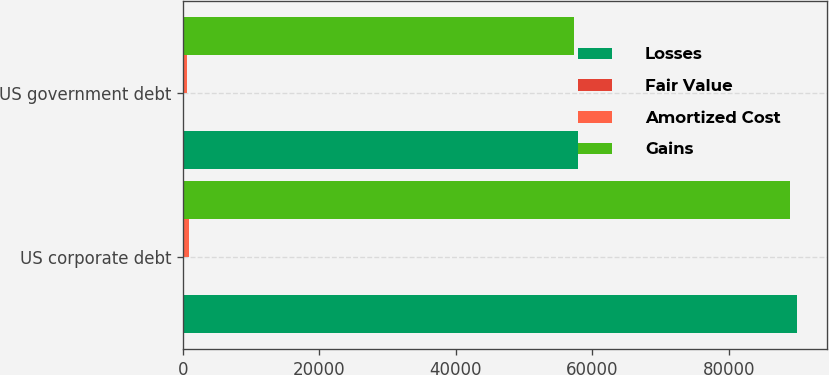<chart> <loc_0><loc_0><loc_500><loc_500><stacked_bar_chart><ecel><fcel>US corporate debt<fcel>US government debt<nl><fcel>Losses<fcel>89956<fcel>57936<nl><fcel>Fair Value<fcel>8<fcel>4<nl><fcel>Amortized Cost<fcel>953<fcel>620<nl><fcel>Gains<fcel>89011<fcel>57320<nl></chart> 